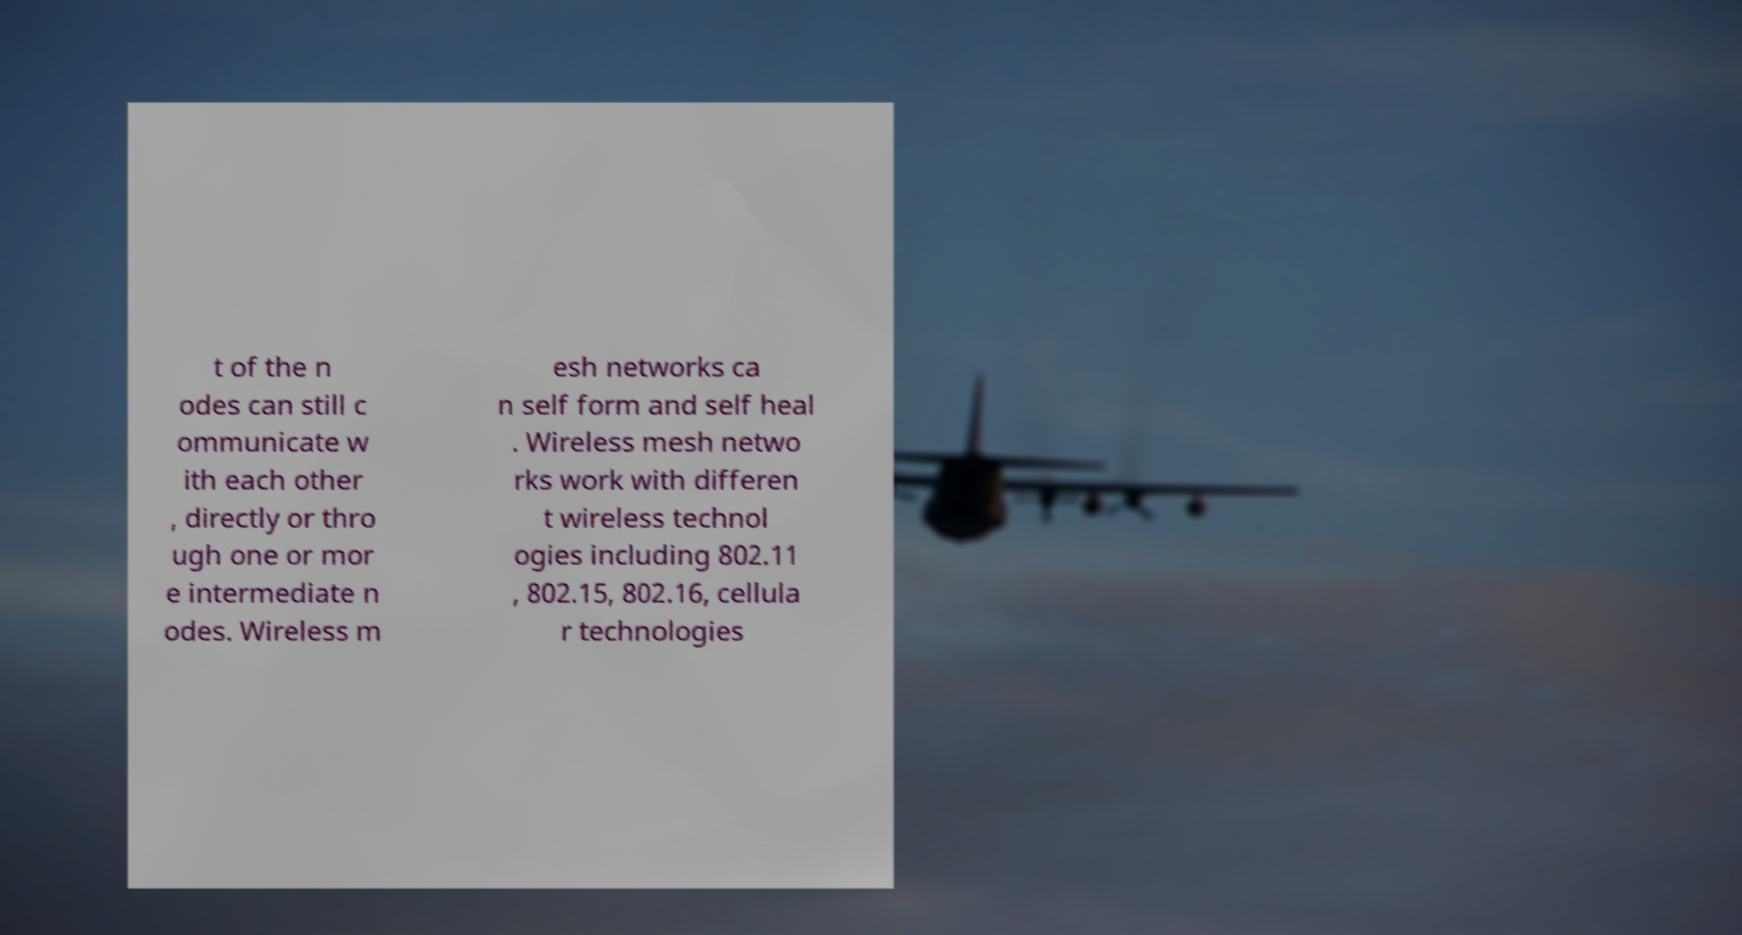For documentation purposes, I need the text within this image transcribed. Could you provide that? t of the n odes can still c ommunicate w ith each other , directly or thro ugh one or mor e intermediate n odes. Wireless m esh networks ca n self form and self heal . Wireless mesh netwo rks work with differen t wireless technol ogies including 802.11 , 802.15, 802.16, cellula r technologies 